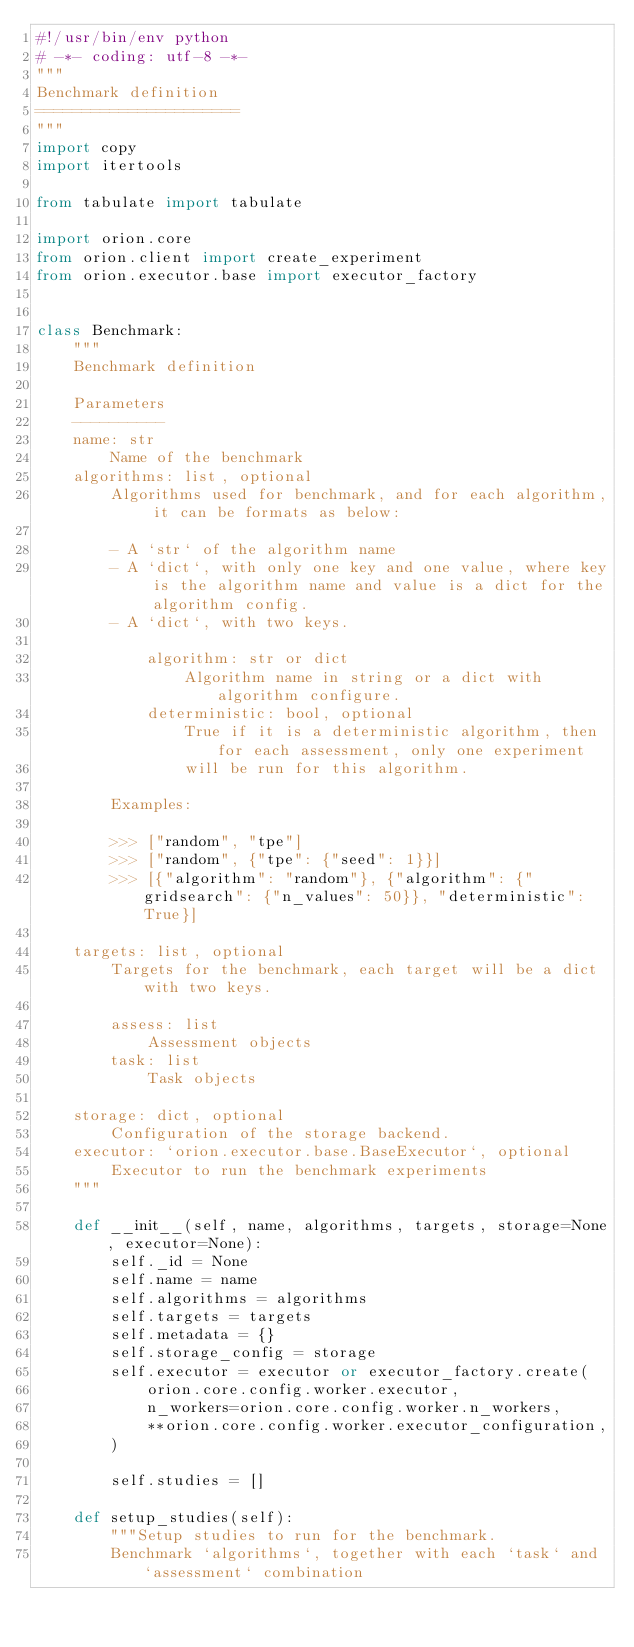<code> <loc_0><loc_0><loc_500><loc_500><_Python_>#!/usr/bin/env python
# -*- coding: utf-8 -*-
"""
Benchmark definition
======================
"""
import copy
import itertools

from tabulate import tabulate

import orion.core
from orion.client import create_experiment
from orion.executor.base import executor_factory


class Benchmark:
    """
    Benchmark definition

    Parameters
    ----------
    name: str
        Name of the benchmark
    algorithms: list, optional
        Algorithms used for benchmark, and for each algorithm, it can be formats as below:

        - A `str` of the algorithm name
        - A `dict`, with only one key and one value, where key is the algorithm name and value is a dict for the algorithm config.
        - A `dict`, with two keys.

            algorithm: str or dict
                Algorithm name in string or a dict with algorithm configure.
            deterministic: bool, optional
                True if it is a deterministic algorithm, then for each assessment, only one experiment
                will be run for this algorithm.

        Examples:

        >>> ["random", "tpe"]
        >>> ["random", {"tpe": {"seed": 1}}]
        >>> [{"algorithm": "random"}, {"algorithm": {"gridsearch": {"n_values": 50}}, "deterministic": True}]

    targets: list, optional
        Targets for the benchmark, each target will be a dict with two keys.

        assess: list
            Assessment objects
        task: list
            Task objects

    storage: dict, optional
        Configuration of the storage backend.
    executor: `orion.executor.base.BaseExecutor`, optional
        Executor to run the benchmark experiments
    """

    def __init__(self, name, algorithms, targets, storage=None, executor=None):
        self._id = None
        self.name = name
        self.algorithms = algorithms
        self.targets = targets
        self.metadata = {}
        self.storage_config = storage
        self.executor = executor or executor_factory.create(
            orion.core.config.worker.executor,
            n_workers=orion.core.config.worker.n_workers,
            **orion.core.config.worker.executor_configuration,
        )

        self.studies = []

    def setup_studies(self):
        """Setup studies to run for the benchmark.
        Benchmark `algorithms`, together with each `task` and `assessment` combination</code> 